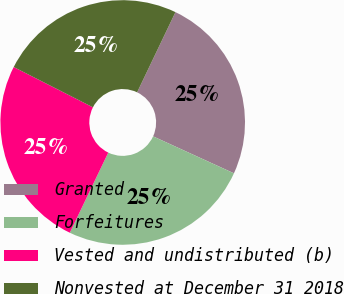Convert chart to OTSL. <chart><loc_0><loc_0><loc_500><loc_500><pie_chart><fcel>Granted<fcel>Forfeitures<fcel>Vested and undistributed (b)<fcel>Nonvested at December 31 2018<nl><fcel>24.73%<fcel>25.3%<fcel>25.37%<fcel>24.61%<nl></chart> 